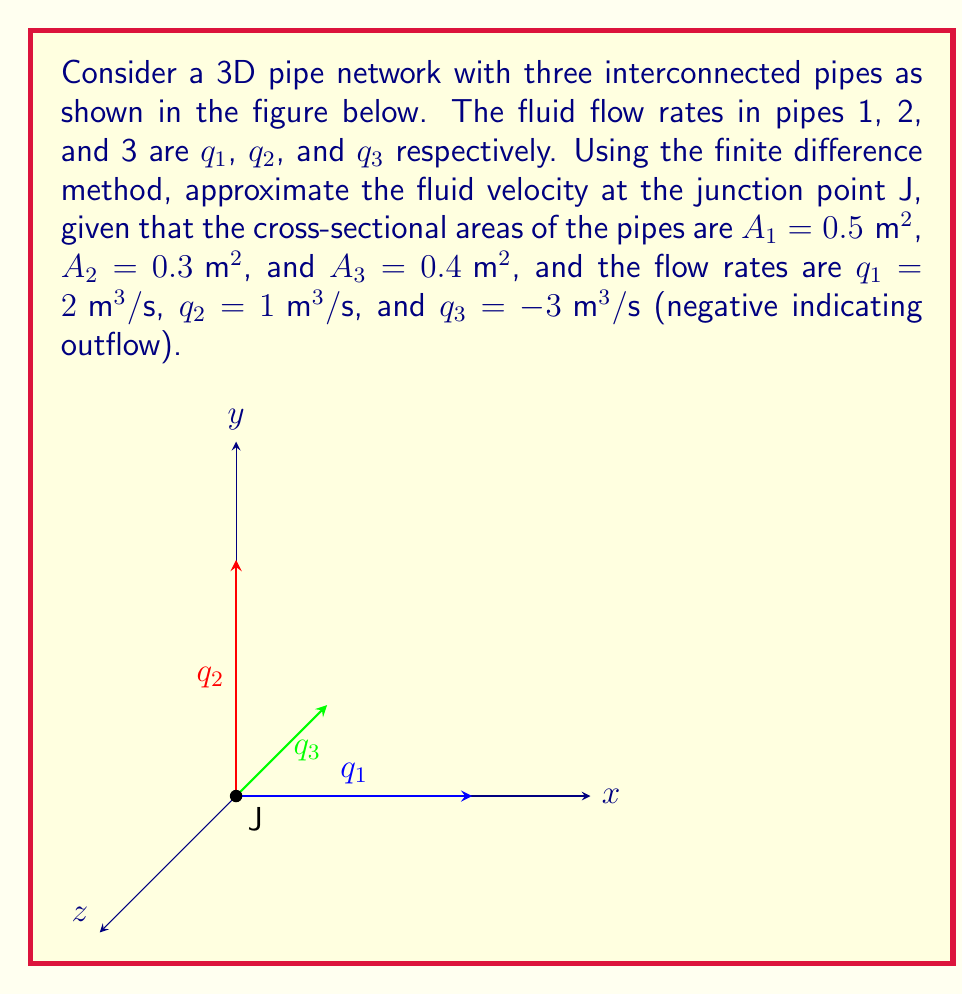Solve this math problem. To approximate the fluid velocity at the junction point J using the finite difference method, we'll follow these steps:

1) First, we need to understand that the velocity at the junction is a vector sum of the velocities in each pipe. We'll use the continuity equation, which states that the net flow rate at a junction is zero:

   $$q_1 + q_2 + q_3 = 0$$

2) The velocity in each pipe can be calculated using the flow rate and cross-sectional area:

   $$v = \frac{q}{A}$$

3) Let's calculate the velocities in each pipe:

   For pipe 1: $v_1 = \frac{q_1}{A_1} = \frac{2}{0.5} = 4 \text{ m/s}$
   For pipe 2: $v_2 = \frac{q_2}{A_2} = \frac{1}{0.3} \approx 3.33 \text{ m/s}$
   For pipe 3: $v_3 = \frac{q_3}{A_3} = \frac{-3}{0.4} = -7.5 \text{ m/s}$

4) Now, we need to consider the direction of these velocities. From the diagram:
   - $v_1$ is in the positive x-direction
   - $v_2$ is in the positive y-direction
   - $v_3$ is in the negative z-direction

5) The velocity at the junction can be approximated as the vector sum of these velocities:

   $$\vec{v}_J = v_1\hat{i} + v_2\hat{j} + v_3\hat{k}$$

6) Substituting the values:

   $$\vec{v}_J = 4\hat{i} + 3.33\hat{j} - 7.5\hat{k}$$

7) The magnitude of this velocity vector is:

   $$|\vec{v}_J| = \sqrt{4^2 + 3.33^2 + (-7.5)^2} \approx 9.17 \text{ m/s}$$

Therefore, the approximate fluid velocity at junction J is 9.17 m/s in the direction given by the vector $4\hat{i} + 3.33\hat{j} - 7.5\hat{k}$.
Answer: $\vec{v}_J = 4\hat{i} + 3.33\hat{j} - 7.5\hat{k}$, $|\vec{v}_J| \approx 9.17 \text{ m/s}$ 